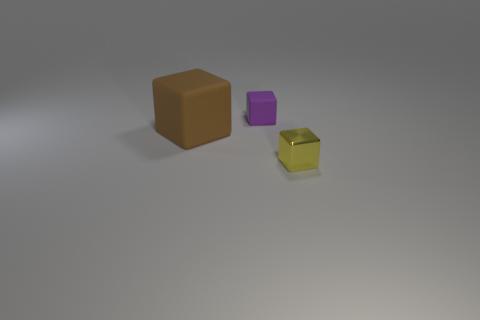Add 2 brown things. How many objects exist? 5 Subtract all cyan cubes. Subtract all brown things. How many objects are left? 2 Add 1 tiny yellow objects. How many tiny yellow objects are left? 2 Add 2 brown matte objects. How many brown matte objects exist? 3 Subtract 1 yellow cubes. How many objects are left? 2 